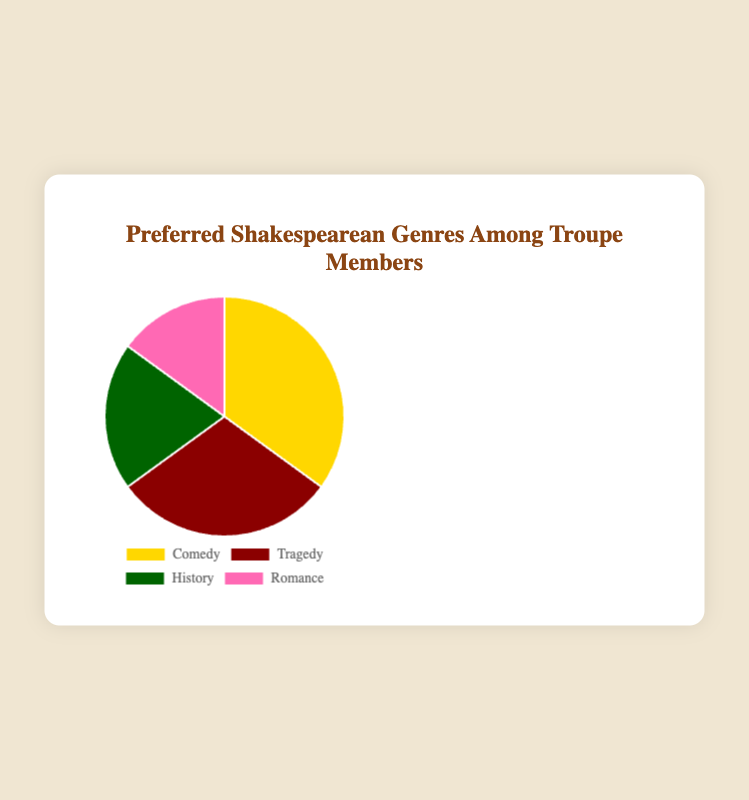What percentage of troupe members prefer Tragedy? The pie chart shows the percentage distribution of preferred Shakespearean genres, with Tragedy representing 30%.
Answer: 30% Which genre is the least preferred among troupe members? From the pie chart, the genre with the smallest percentage is Romance, accounting for 15% of the preferences.
Answer: Romance What is the total percentage of troupe members who prefer either Comedy or History? According to the pie chart, Comedy is preferred by 35% and History by 20%. Adding these together gives us 35% + 20% = 55%.
Answer: 55% Which genre has a higher preference, Romance or Tragedy, and by how much? The pie chart indicates that Tragedy is preferred by 30% and Romance by 15%. The difference is 30% - 15% = 15%.
Answer: Tragedy by 15% What is the combined percentage of troupe members who prefer either a Comedy or Tragedy genre? The pie chart shows that Comedy accounts for 35% and Tragedy for 30%. Therefore, the combined percentage is 35% + 30% = 65%.
Answer: 65% How does the preference for Comedy compare to that of History? The chart shows Comedy at 35% and History at 20%. Comparison-wise, 35% > 20%, so Comedy is more preferred than History.
Answer: Comedy is more preferred How many percentage points higher is the preference for Comedy compared to Romance? Comedy is shown as 35% and Romance as 15% on the pie chart. The difference is 35% - 15% = 20 percentage points.
Answer: 20 percentage points If you combine the preferences for Tragedy and Romance, how does it compare to the preference for Comedy? The pie chart indicates Tragedy (30%) + Romance (15%) equals 45%. Comedy alone is 35%. Therefore, 45% > 35%.
Answer: Tragedy + Romance is higher Which color corresponds to the genre "History" in the pie chart? The pie chart showing distinct colors has "History" marked in green.
Answer: Green What fraction of the troupe prefers either History or Romance? From the chart, History is 20% and Romance is 15%. Adding these gives 20% + 15% = 35%. The fraction is 35% out of 100%, which reduces to 35/100 or 7/20.
Answer: 7/20 